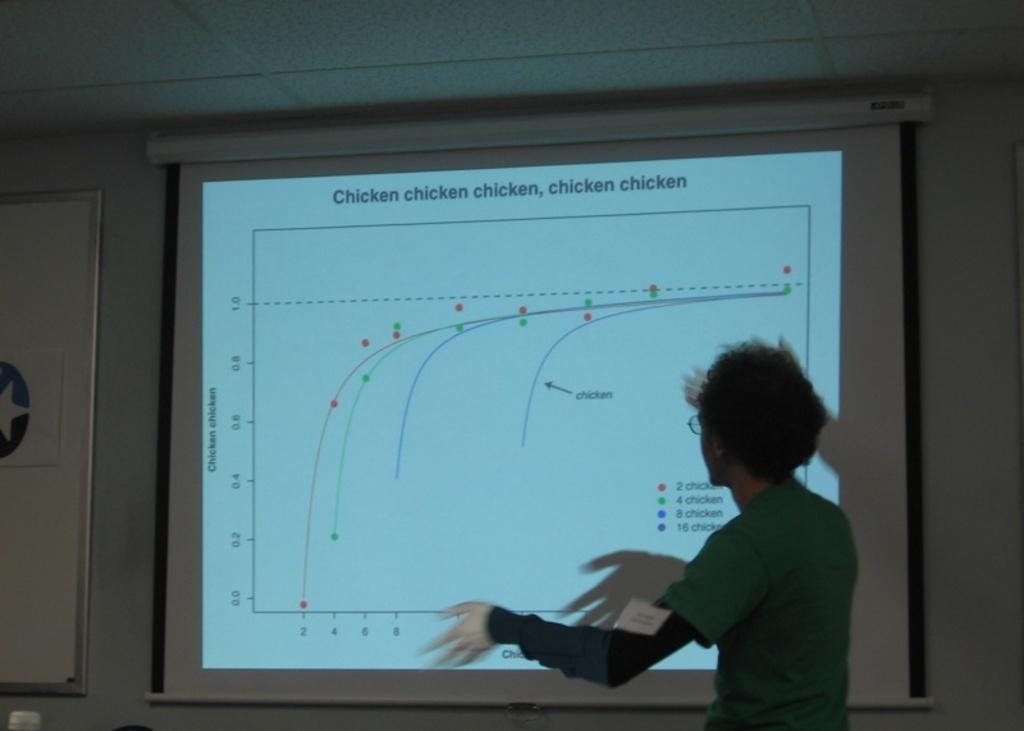Provide a one-sentence caption for the provided image. A person is explaining a chart projected on the wall about chicken. 